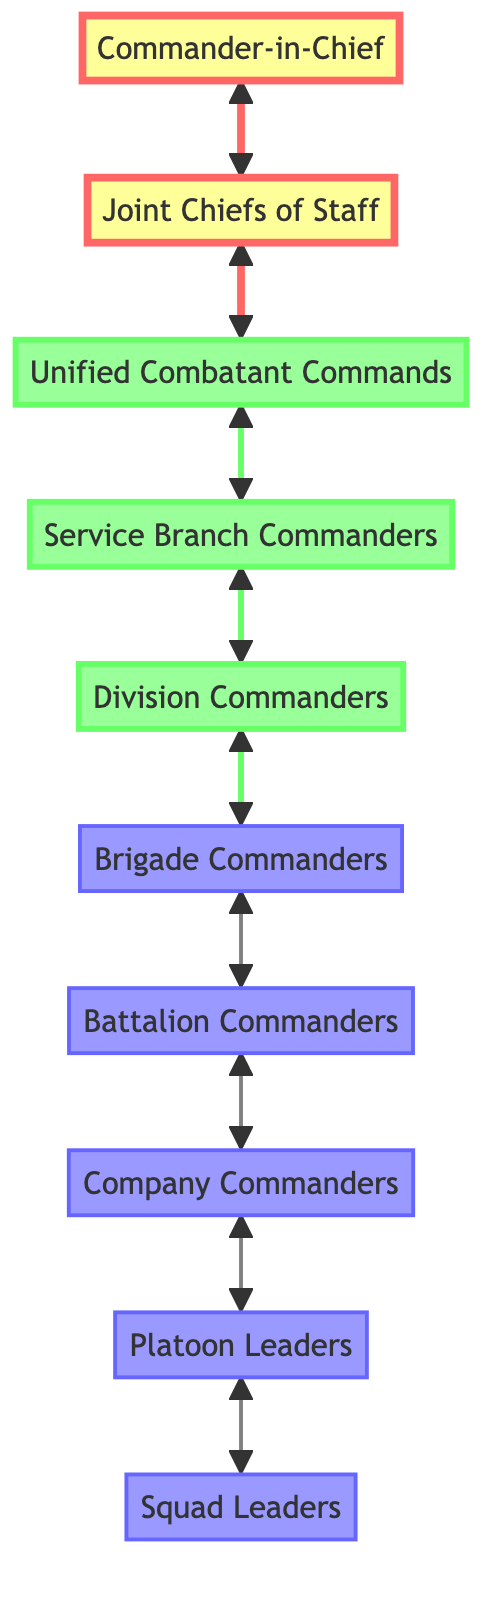What is the top role in the diagram? The top role in the diagram is the "Commander-in-Chief," as indicated by its position and label.
Answer: Commander-in-Chief How many total roles are depicted in the diagram? By counting the specific titles listed, there are ten distinct roles in the diagram.
Answer: 10 Which role is directly connected to the Unified Combatant Commands? The "Joint Chiefs of Staff" is directly connected to the Unified Combatant Commands, showing an advisory relationship as depicted in the connections.
Answer: Joint Chiefs of Staff What relationship exists between Division Commanders and Brigade Commanders? A direct relationship exists where Division Commanders oversee and provide direction to Brigade Commanders according to the chain of command outlined in the diagram.
Answer: Division Commanders What is the next immediate role below Service Branch Commanders? The next immediate role below Service Branch Commanders is Division Commanders, indicating a tiered structure in the command hierarchy.
Answer: Division Commanders How many edges connect the Commander-in-Chief to other roles? There is one edge connecting the Commander-in-Chief to the Joint Chiefs of Staff, indicating a direct relationship only to that specific role.
Answer: 1 Which role is responsible for overseeing tactical deployments? The "Battalion Commanders" are responsible for overseeing tactical deployments, as specified in their description within the diagram.
Answer: Battalion Commanders What role comes before Company Commanders in the hierarchy? The role that comes before Company Commanders in the hierarchy is Battalion Commanders, established through the direct relationship depicted in the diagram.
Answer: Battalion Commanders What color reflects the mid-level roles in the diagram? The mid-level roles are filled in a green shade, indicating their status in the hierarchy relative to top and lower roles.
Answer: green How are the relationships characterized between the roles in this diagram? The relationships are characterized by direct connections indicating command flow and advisory roles among the various levels of command in the military operations structure.
Answer: direct connections 